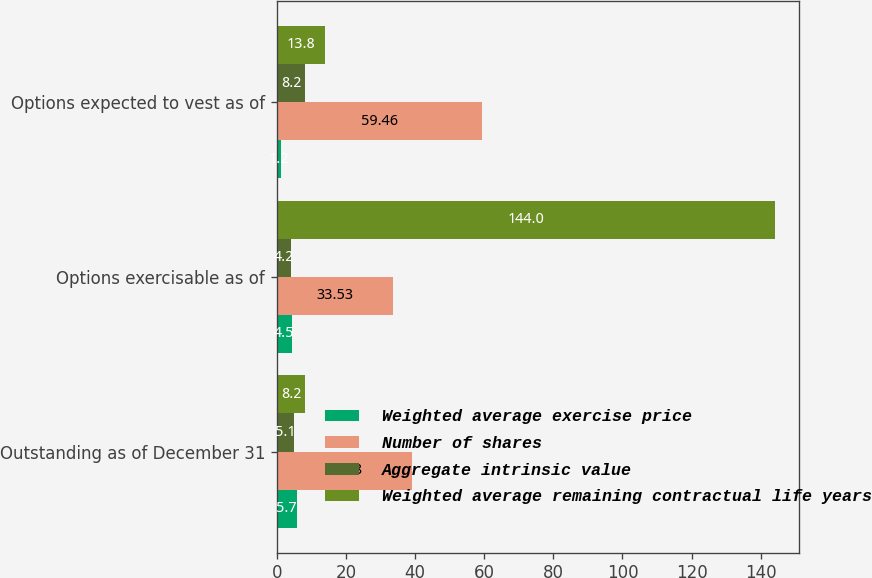Convert chart to OTSL. <chart><loc_0><loc_0><loc_500><loc_500><stacked_bar_chart><ecel><fcel>Outstanding as of December 31<fcel>Options exercisable as of<fcel>Options expected to vest as of<nl><fcel>Weighted average exercise price<fcel>5.7<fcel>4.5<fcel>1.2<nl><fcel>Number of shares<fcel>39.08<fcel>33.53<fcel>59.46<nl><fcel>Aggregate intrinsic value<fcel>5.1<fcel>4.2<fcel>8.2<nl><fcel>Weighted average remaining contractual life years<fcel>8.2<fcel>144<fcel>13.8<nl></chart> 